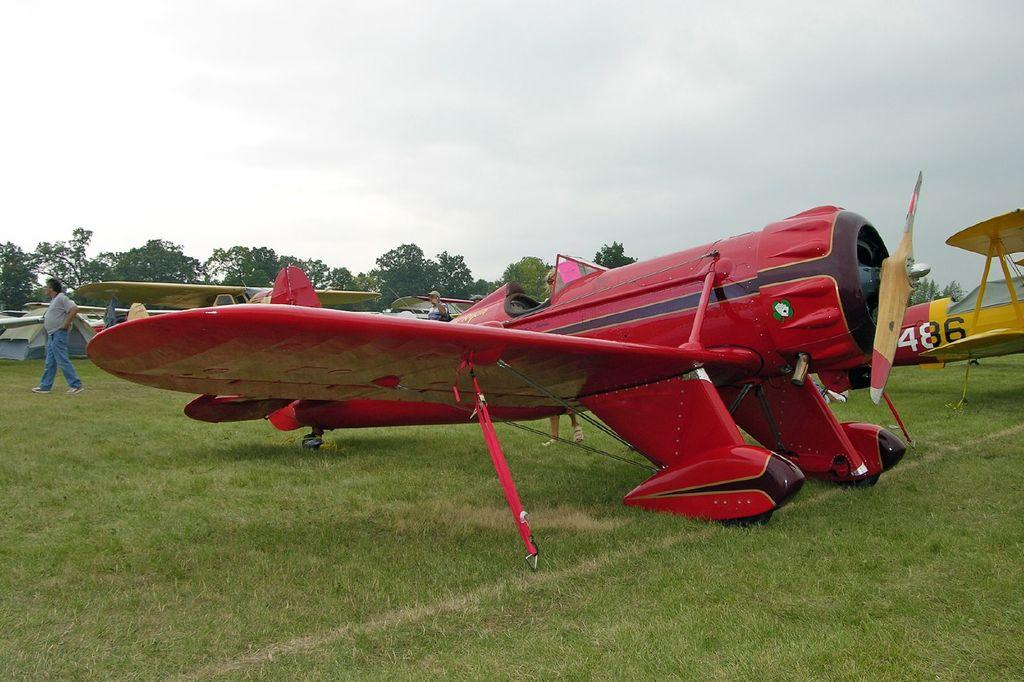<image>
Describe the image concisely. a few planes in a field, one of them plane 486. 